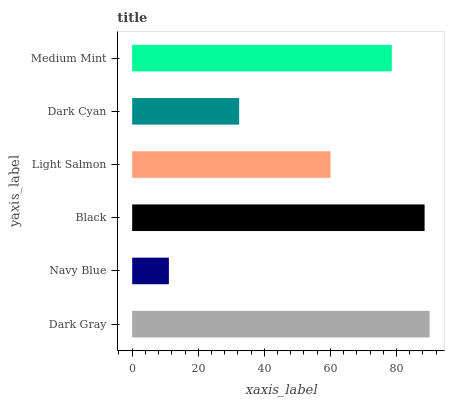Is Navy Blue the minimum?
Answer yes or no. Yes. Is Dark Gray the maximum?
Answer yes or no. Yes. Is Black the minimum?
Answer yes or no. No. Is Black the maximum?
Answer yes or no. No. Is Black greater than Navy Blue?
Answer yes or no. Yes. Is Navy Blue less than Black?
Answer yes or no. Yes. Is Navy Blue greater than Black?
Answer yes or no. No. Is Black less than Navy Blue?
Answer yes or no. No. Is Medium Mint the high median?
Answer yes or no. Yes. Is Light Salmon the low median?
Answer yes or no. Yes. Is Dark Gray the high median?
Answer yes or no. No. Is Medium Mint the low median?
Answer yes or no. No. 